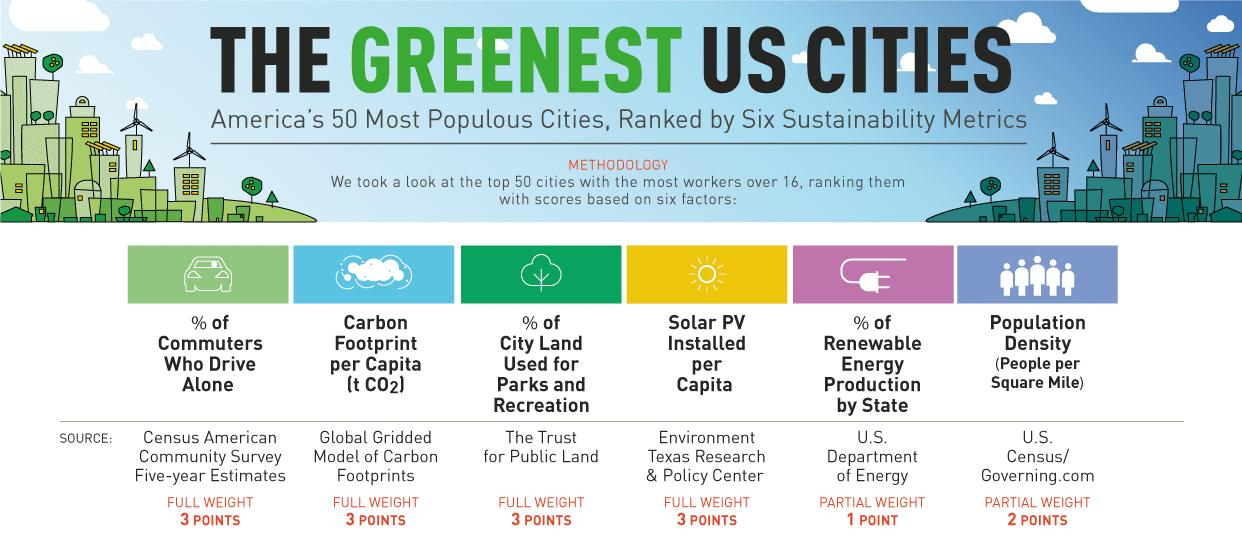Indicate a few pertinent items in this graphic. The land use for the park and recreation has been sourced from The Trust for Public Land. The weightage given for population density is 2 points. 